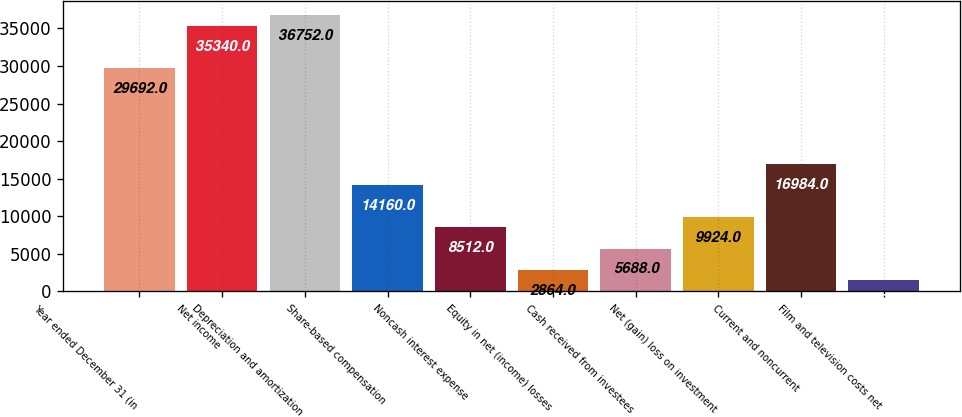Convert chart to OTSL. <chart><loc_0><loc_0><loc_500><loc_500><bar_chart><fcel>Year ended December 31 (in<fcel>Net income<fcel>Depreciation and amortization<fcel>Share-based compensation<fcel>Noncash interest expense<fcel>Equity in net (income) losses<fcel>Cash received from investees<fcel>Net (gain) loss on investment<fcel>Current and noncurrent<fcel>Film and television costs net<nl><fcel>29692<fcel>35340<fcel>36752<fcel>14160<fcel>8512<fcel>2864<fcel>5688<fcel>9924<fcel>16984<fcel>1452<nl></chart> 